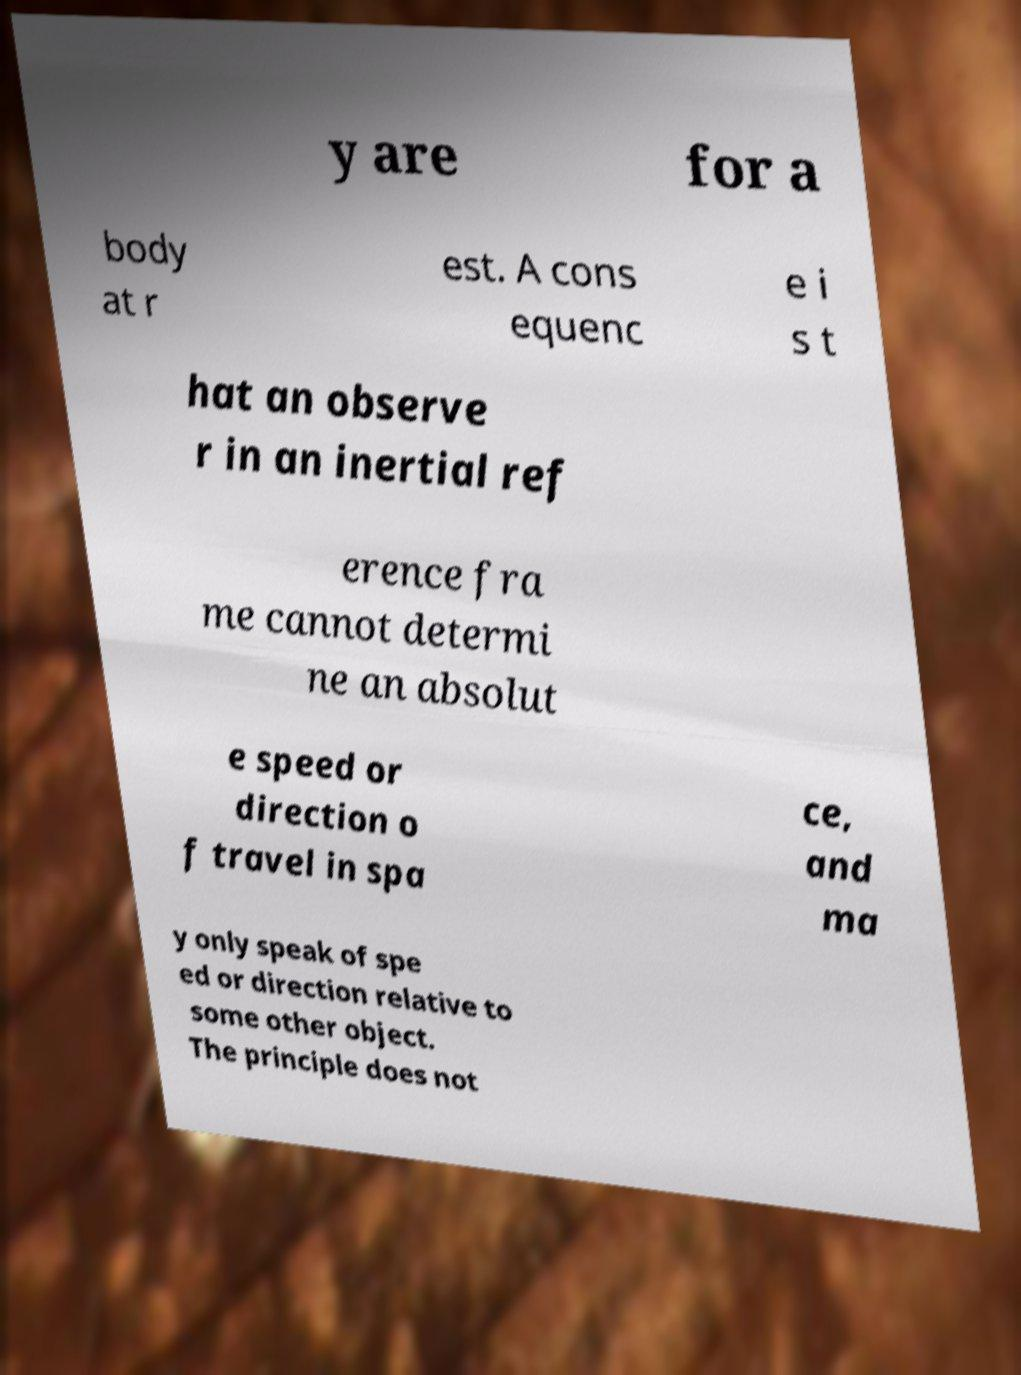Could you extract and type out the text from this image? y are for a body at r est. A cons equenc e i s t hat an observe r in an inertial ref erence fra me cannot determi ne an absolut e speed or direction o f travel in spa ce, and ma y only speak of spe ed or direction relative to some other object. The principle does not 